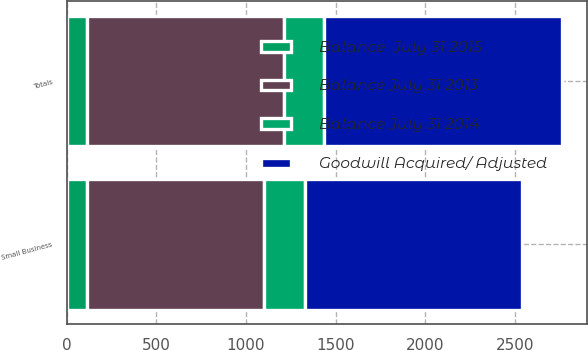<chart> <loc_0><loc_0><loc_500><loc_500><stacked_bar_chart><ecel><fcel>Small Business<fcel>Totals<nl><fcel>Balance July 31 2013<fcel>988<fcel>1100<nl><fcel>Balance July 31 2014<fcel>225<fcel>223<nl><fcel>Goodwill Acquired/ Adjusted<fcel>1213<fcel>1323<nl><fcel>Balance  July 31 2015<fcel>114<fcel>114<nl></chart> 